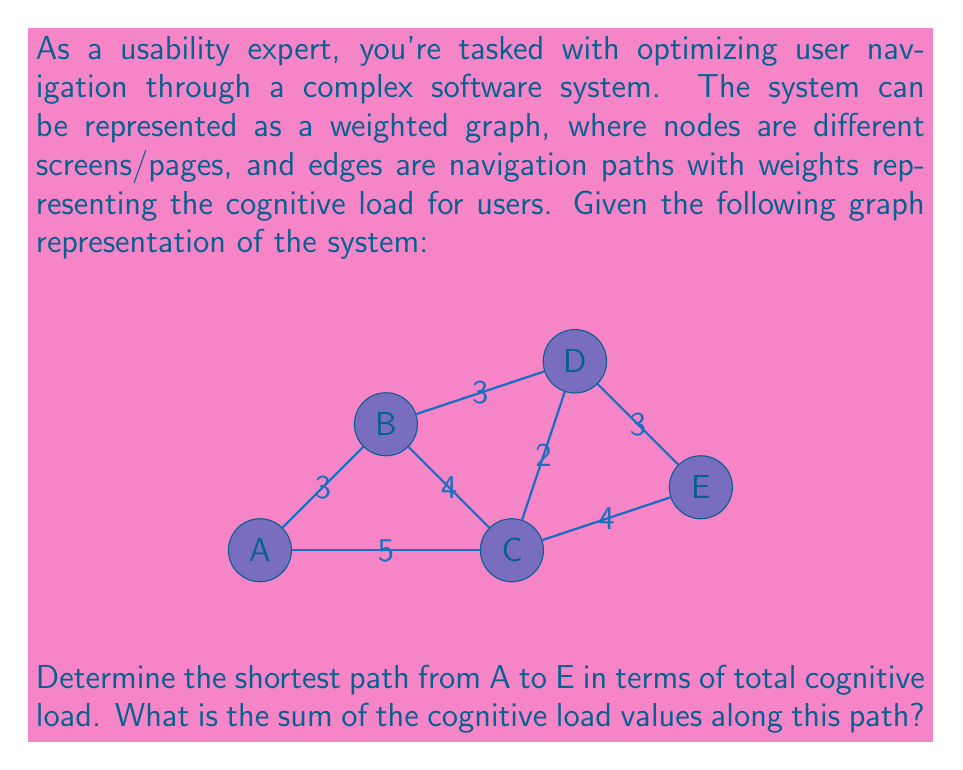Show me your answer to this math problem. To solve this problem, we'll use Dijkstra's algorithm to find the shortest path from A to E. Here's a step-by-step explanation:

1) Initialize:
   - Distance to A = 0
   - Distance to all other nodes = ∞
   - Set of unvisited nodes = {A, B, C, D, E}

2) Start from node A:
   - Update distances:
     A to B: 3
     A to C: 5
   - Mark A as visited

3) Choose the node with the smallest distance (B):
   - Update distances:
     B to D: 3 + 3 = 6
   - Mark B as visited

4) Choose the node with the smallest distance (C):
   - Update distances:
     C to D: 5 + 2 = 7 (not smaller than current 6)
     C to E: 5 + 4 = 9
   - Mark C as visited

5) Choose the node with the smallest distance (D):
   - Update distances:
     D to E: 6 + 3 = 9 (not smaller than current 9)
   - Mark D as visited

6) The only remaining node is E, which we've reached with a total distance of 9.

The shortest path is A → C → E, with a total cognitive load of 5 + 4 = 9.
Answer: 9 